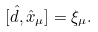<formula> <loc_0><loc_0><loc_500><loc_500>[ \hat { d } , \hat { x } _ { \mu } ] = \xi _ { \mu } .</formula> 